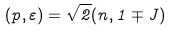Convert formula to latex. <formula><loc_0><loc_0><loc_500><loc_500>( p , \varepsilon ) = \sqrt { 2 } ( n , 1 \mp J )</formula> 